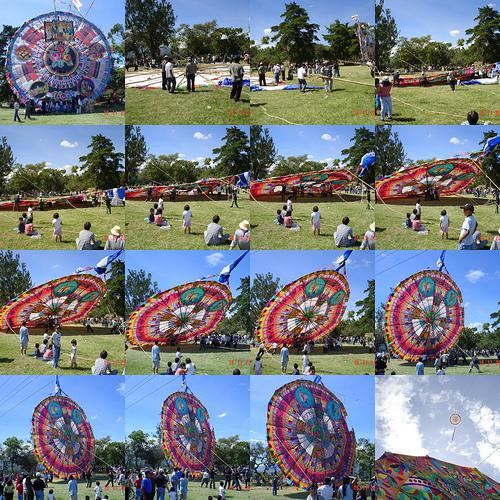Question: what are they doing in second scene?
Choices:
A. Holding string.
B. Running.
C. Figuring out which way the wind is blowing.
D. Raising the kite.
Answer with the letter. Answer: D Question: what is taking place?
Choices:
A. Kite flying.
B. Playing on a beach.
C. Badminton.
D. Suntanning.
Answer with the letter. Answer: A Question: where is this scene?
Choices:
A. In a field.
B. Outside.
C. At a picnic.
D. Park.
Answer with the letter. Answer: D Question: where are people sitting?
Choices:
A. Grass.
B. On blankets.
C. At a picnic table.
D. In a field.
Answer with the letter. Answer: A Question: how is the weather?
Choices:
A. Clear and nice.
B. Sunny.
C. Overcast.
D. Windy and cold.
Answer with the letter. Answer: A Question: when is this?
Choices:
A. Afternoon.
B. Day time.
C. Morning.
D. Night time.
Answer with the letter. Answer: B 